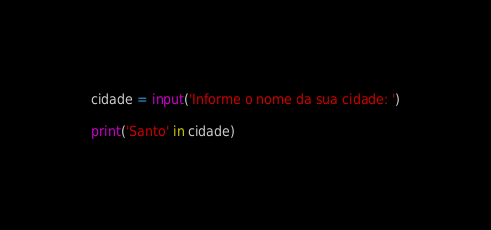<code> <loc_0><loc_0><loc_500><loc_500><_Python_>cidade = input('Informe o nome da sua cidade: ')

print('Santo' in cidade)
</code> 